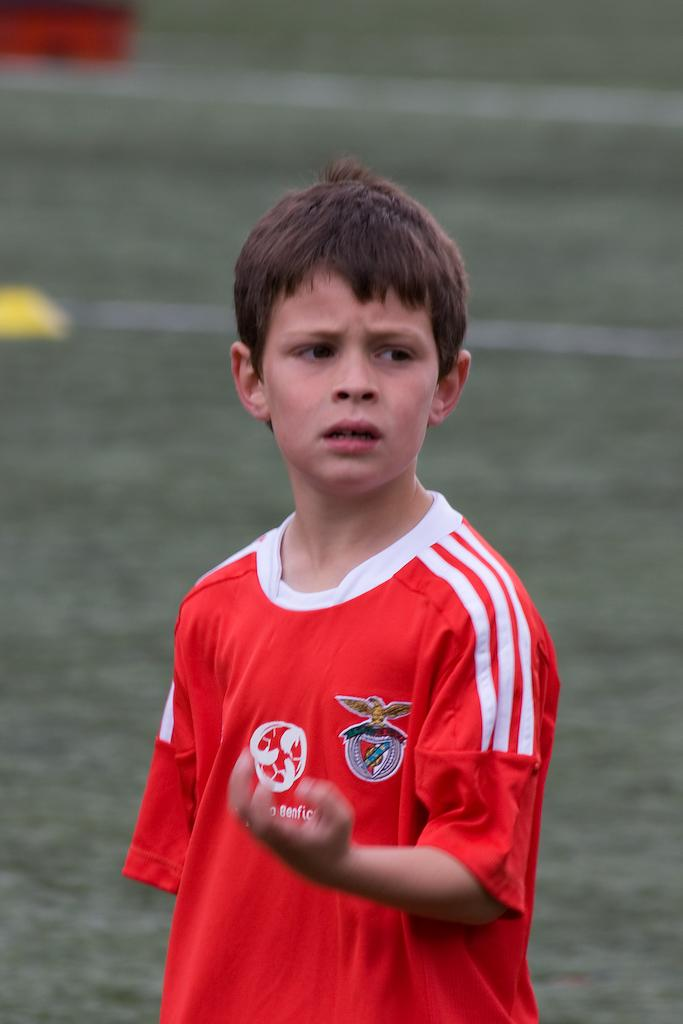What is the main subject of the image? There is a boy in the image. What is the boy doing in the image? The boy is standing. What is the boy wearing in the image? The boy is wearing a red color t-shirt. Can you describe the background of the image? The background of the image is blurred. What type of agreement does the boy have with his daughter in the image? There is no mention of a daughter in the image, and therefore no agreement can be discussed. 